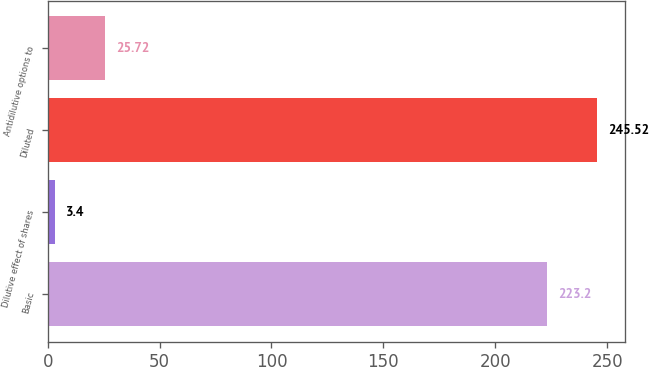<chart> <loc_0><loc_0><loc_500><loc_500><bar_chart><fcel>Basic<fcel>Dilutive effect of shares<fcel>Diluted<fcel>Antidilutive options to<nl><fcel>223.2<fcel>3.4<fcel>245.52<fcel>25.72<nl></chart> 